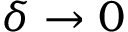<formula> <loc_0><loc_0><loc_500><loc_500>\delta \to 0</formula> 